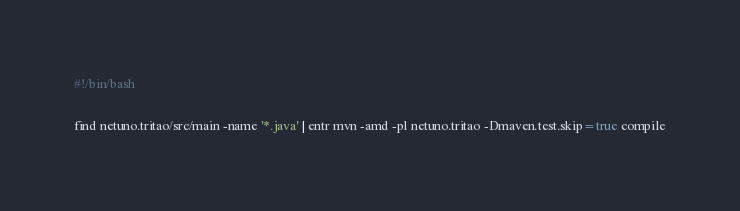Convert code to text. <code><loc_0><loc_0><loc_500><loc_500><_Bash_>#!/bin/bash

find netuno.tritao/src/main -name '*.java' | entr mvn -amd -pl netuno.tritao -Dmaven.test.skip=true compile

</code> 